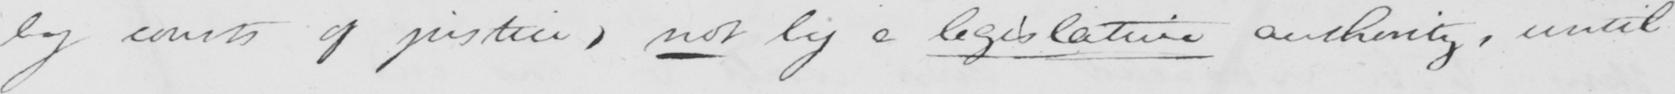What is written in this line of handwriting? by courts of justices , not by a legislative authority , until 